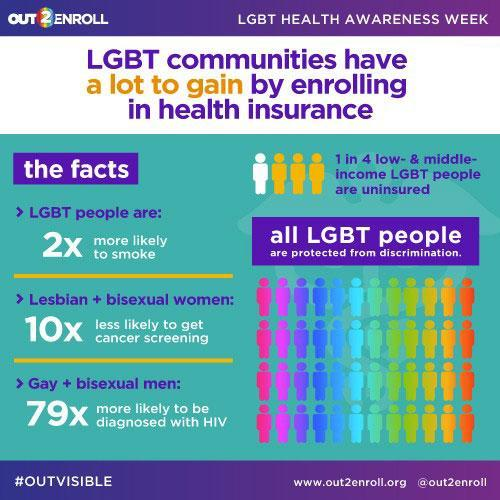What is two-times likely to be done by LGBT people?
Answer the question with a short phrase. smoke 